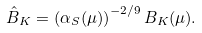Convert formula to latex. <formula><loc_0><loc_0><loc_500><loc_500>\hat { B } _ { K } = \left ( \alpha _ { S } ( \mu ) \right ) ^ { - 2 / 9 } B _ { K } ( \mu ) .</formula> 